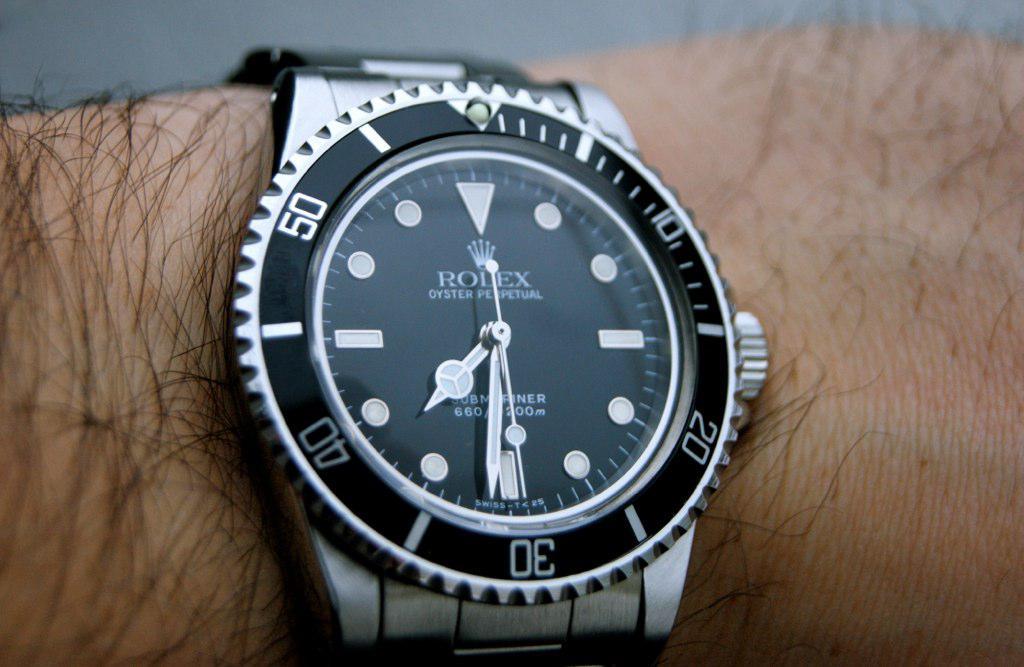What time is it?
Your answer should be very brief. 7:31. What brand is the watch?
Provide a succinct answer. Rolex. 